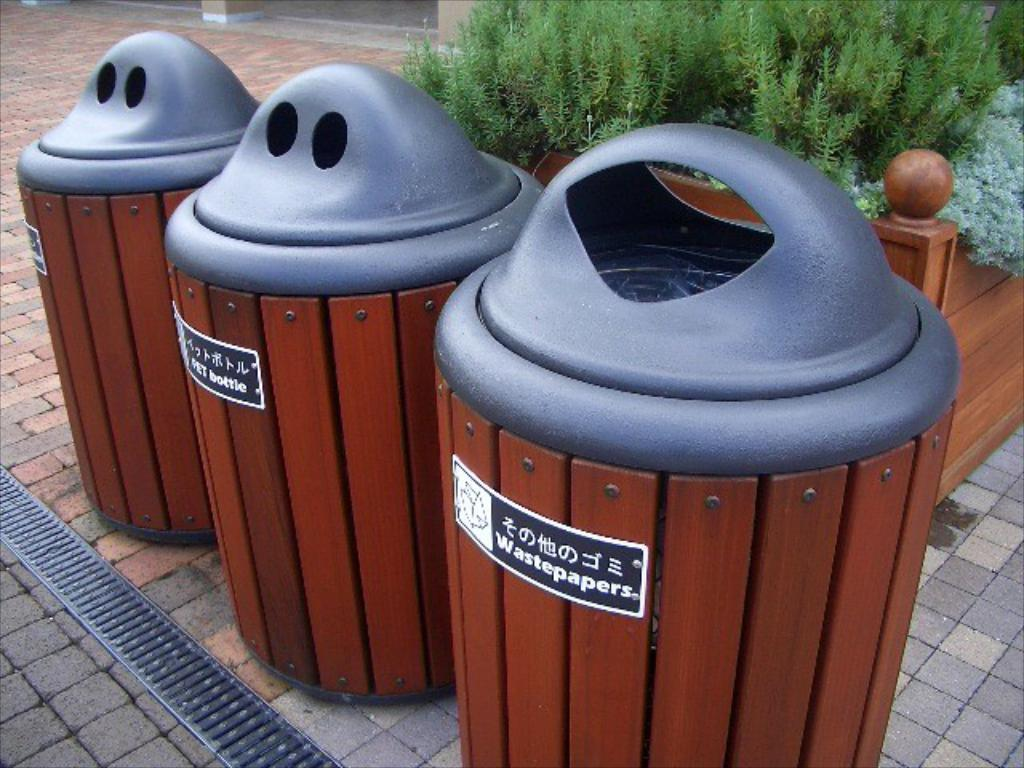<image>
Offer a succinct explanation of the picture presented. the words wastepaper is on the trash can 